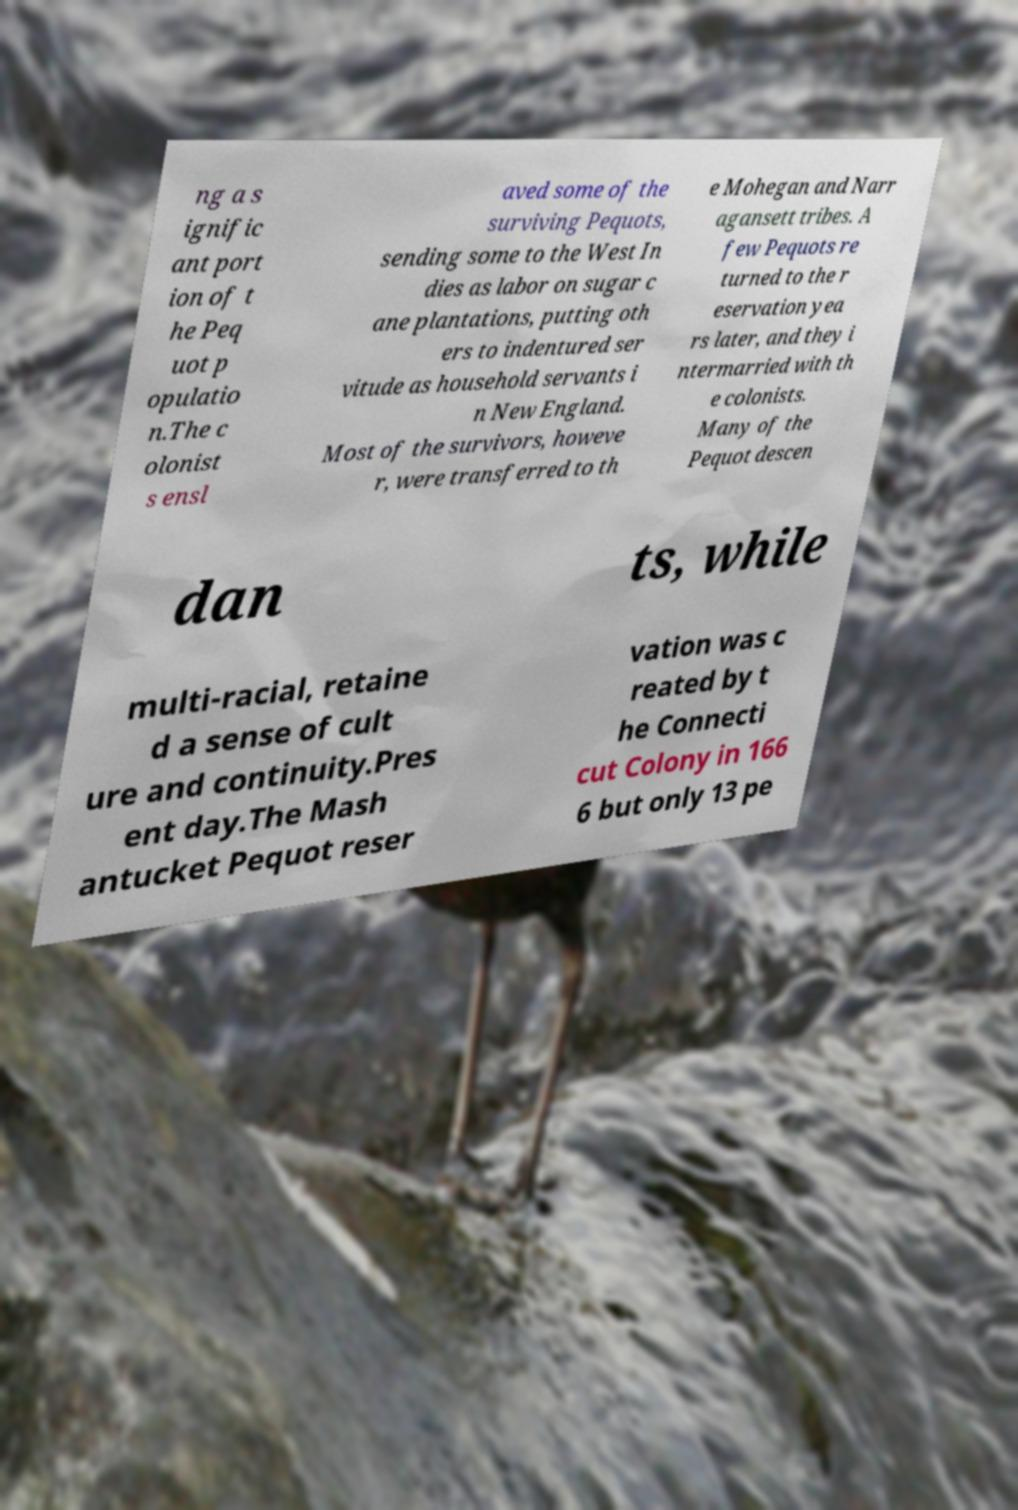For documentation purposes, I need the text within this image transcribed. Could you provide that? ng a s ignific ant port ion of t he Peq uot p opulatio n.The c olonist s ensl aved some of the surviving Pequots, sending some to the West In dies as labor on sugar c ane plantations, putting oth ers to indentured ser vitude as household servants i n New England. Most of the survivors, howeve r, were transferred to th e Mohegan and Narr agansett tribes. A few Pequots re turned to the r eservation yea rs later, and they i ntermarried with th e colonists. Many of the Pequot descen dan ts, while multi-racial, retaine d a sense of cult ure and continuity.Pres ent day.The Mash antucket Pequot reser vation was c reated by t he Connecti cut Colony in 166 6 but only 13 pe 